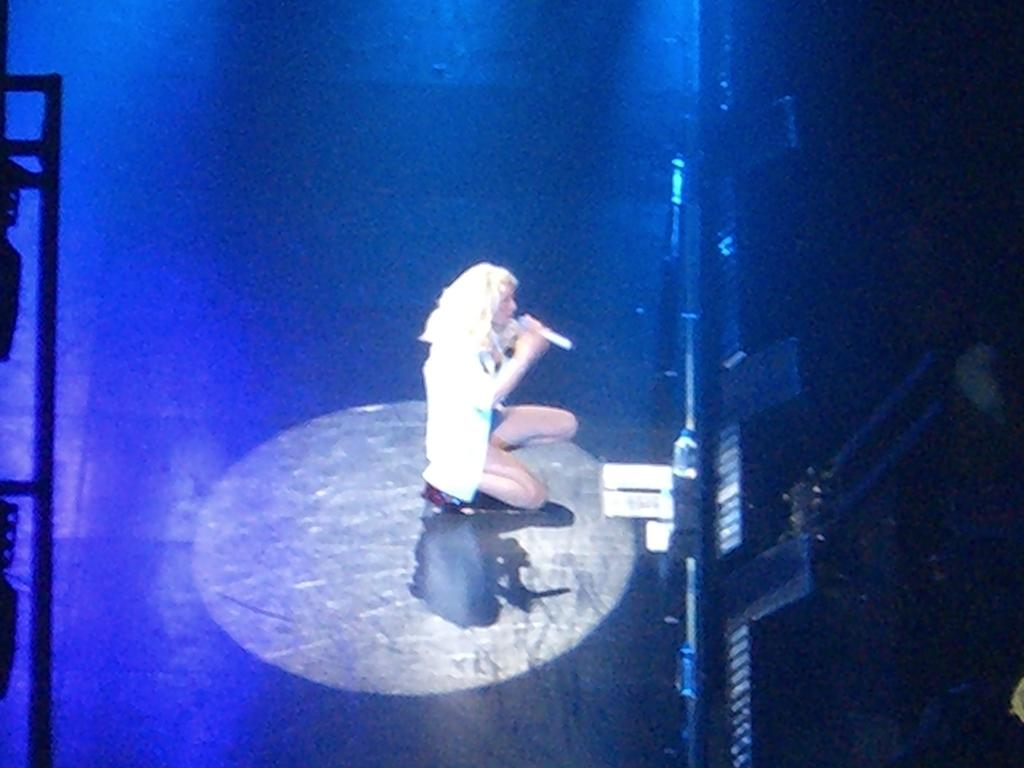Who is the main subject in the image? There is a woman in the image. What is the woman doing in the image? The woman is kneeling down on the floor. What is the woman holding in her hand? The woman is holding a microphone in her hand. What else can be seen in the image besides the woman? There are some objects visible in the image. What type of fear can be seen on the woman's face in the image? There is no indication of fear on the woman's face in the image. 